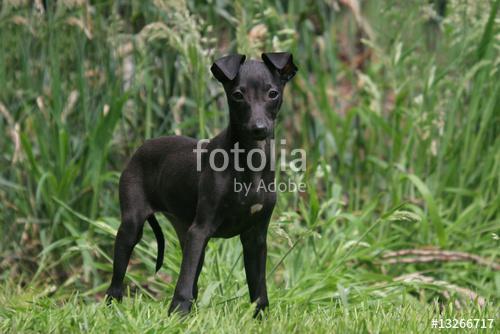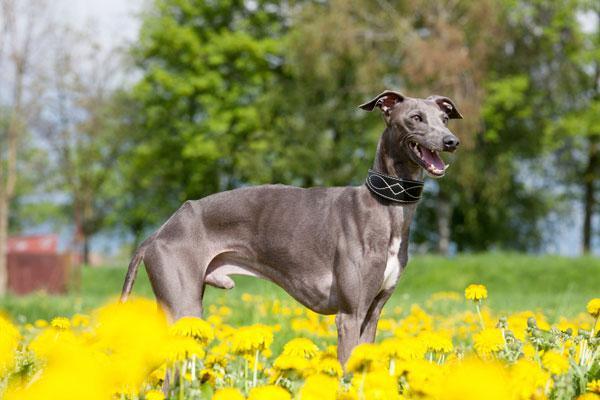The first image is the image on the left, the second image is the image on the right. For the images displayed, is the sentence "An image shows a single dog bounding across a field, with its head partially forward." factually correct? Answer yes or no. No. The first image is the image on the left, the second image is the image on the right. Given the left and right images, does the statement "An image contains exactly two dogs." hold true? Answer yes or no. No. 